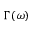Convert formula to latex. <formula><loc_0><loc_0><loc_500><loc_500>\Gamma ( \omega )</formula> 